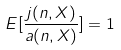<formula> <loc_0><loc_0><loc_500><loc_500>E [ \frac { j ( n , X ) } { a ( n , X ) } ] = 1</formula> 